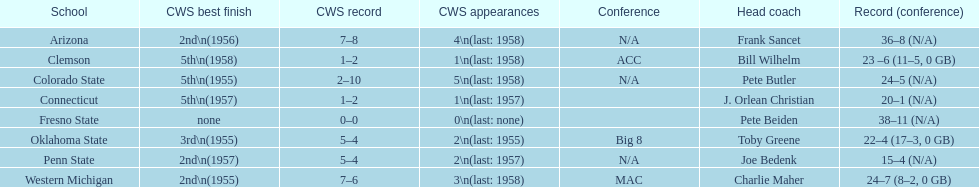How many teams reached their highest cws ranking in 1955? 3. 